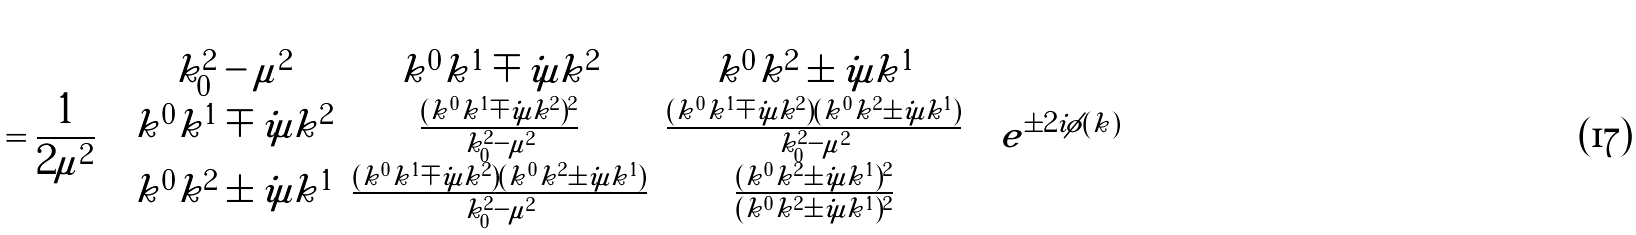Convert formula to latex. <formula><loc_0><loc_0><loc_500><loc_500>= \frac { 1 } { 2 \mu ^ { 2 } } \left ( \begin{array} { c c c } k ^ { 2 } _ { 0 } - \mu ^ { 2 } & k ^ { 0 } k ^ { 1 } \mp i \mu k ^ { 2 } & k ^ { 0 } k ^ { 2 } \pm i \mu k ^ { 1 } \\ k ^ { 0 } k ^ { 1 } \mp i \mu k ^ { 2 } & \frac { ( k ^ { 0 } k ^ { 1 } \mp i \mu k ^ { 2 } ) ^ { 2 } } { k ^ { 2 } _ { 0 } - \mu ^ { 2 } } & \frac { ( k ^ { 0 } k ^ { 1 } \mp i \mu k ^ { 2 } ) ( k ^ { 0 } k ^ { 2 } \pm i \mu k ^ { 1 } ) } { k ^ { 2 } _ { 0 } - \mu ^ { 2 } } \\ k ^ { 0 } k ^ { 2 } \pm i \mu k ^ { 1 } & \frac { ( k ^ { 0 } k ^ { 1 } \mp i \mu k ^ { 2 } ) ( k ^ { 0 } k ^ { 2 } \pm i \mu k ^ { 1 } ) } { k ^ { 2 } _ { 0 } - \mu ^ { 2 } } & \frac { ( k ^ { 0 } k ^ { 2 } \pm i \mu k ^ { 1 } ) ^ { 2 } } { ( k ^ { 0 } k ^ { 2 } \pm i \mu k ^ { 1 } ) ^ { 2 } } \end{array} \right ) e ^ { \pm 2 i \phi ( k ) }</formula> 